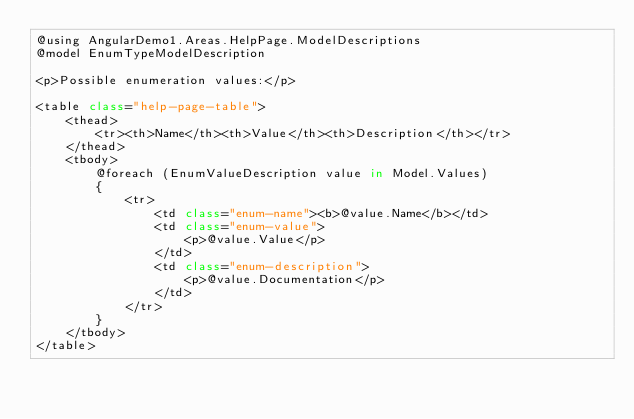Convert code to text. <code><loc_0><loc_0><loc_500><loc_500><_C#_>@using AngularDemo1.Areas.HelpPage.ModelDescriptions
@model EnumTypeModelDescription

<p>Possible enumeration values:</p>

<table class="help-page-table">
    <thead>
        <tr><th>Name</th><th>Value</th><th>Description</th></tr>
    </thead>
    <tbody>
        @foreach (EnumValueDescription value in Model.Values)
        {
            <tr>
                <td class="enum-name"><b>@value.Name</b></td>
                <td class="enum-value">
                    <p>@value.Value</p>
                </td>
                <td class="enum-description">
                    <p>@value.Documentation</p>
                </td>
            </tr>
        }
    </tbody>
</table></code> 